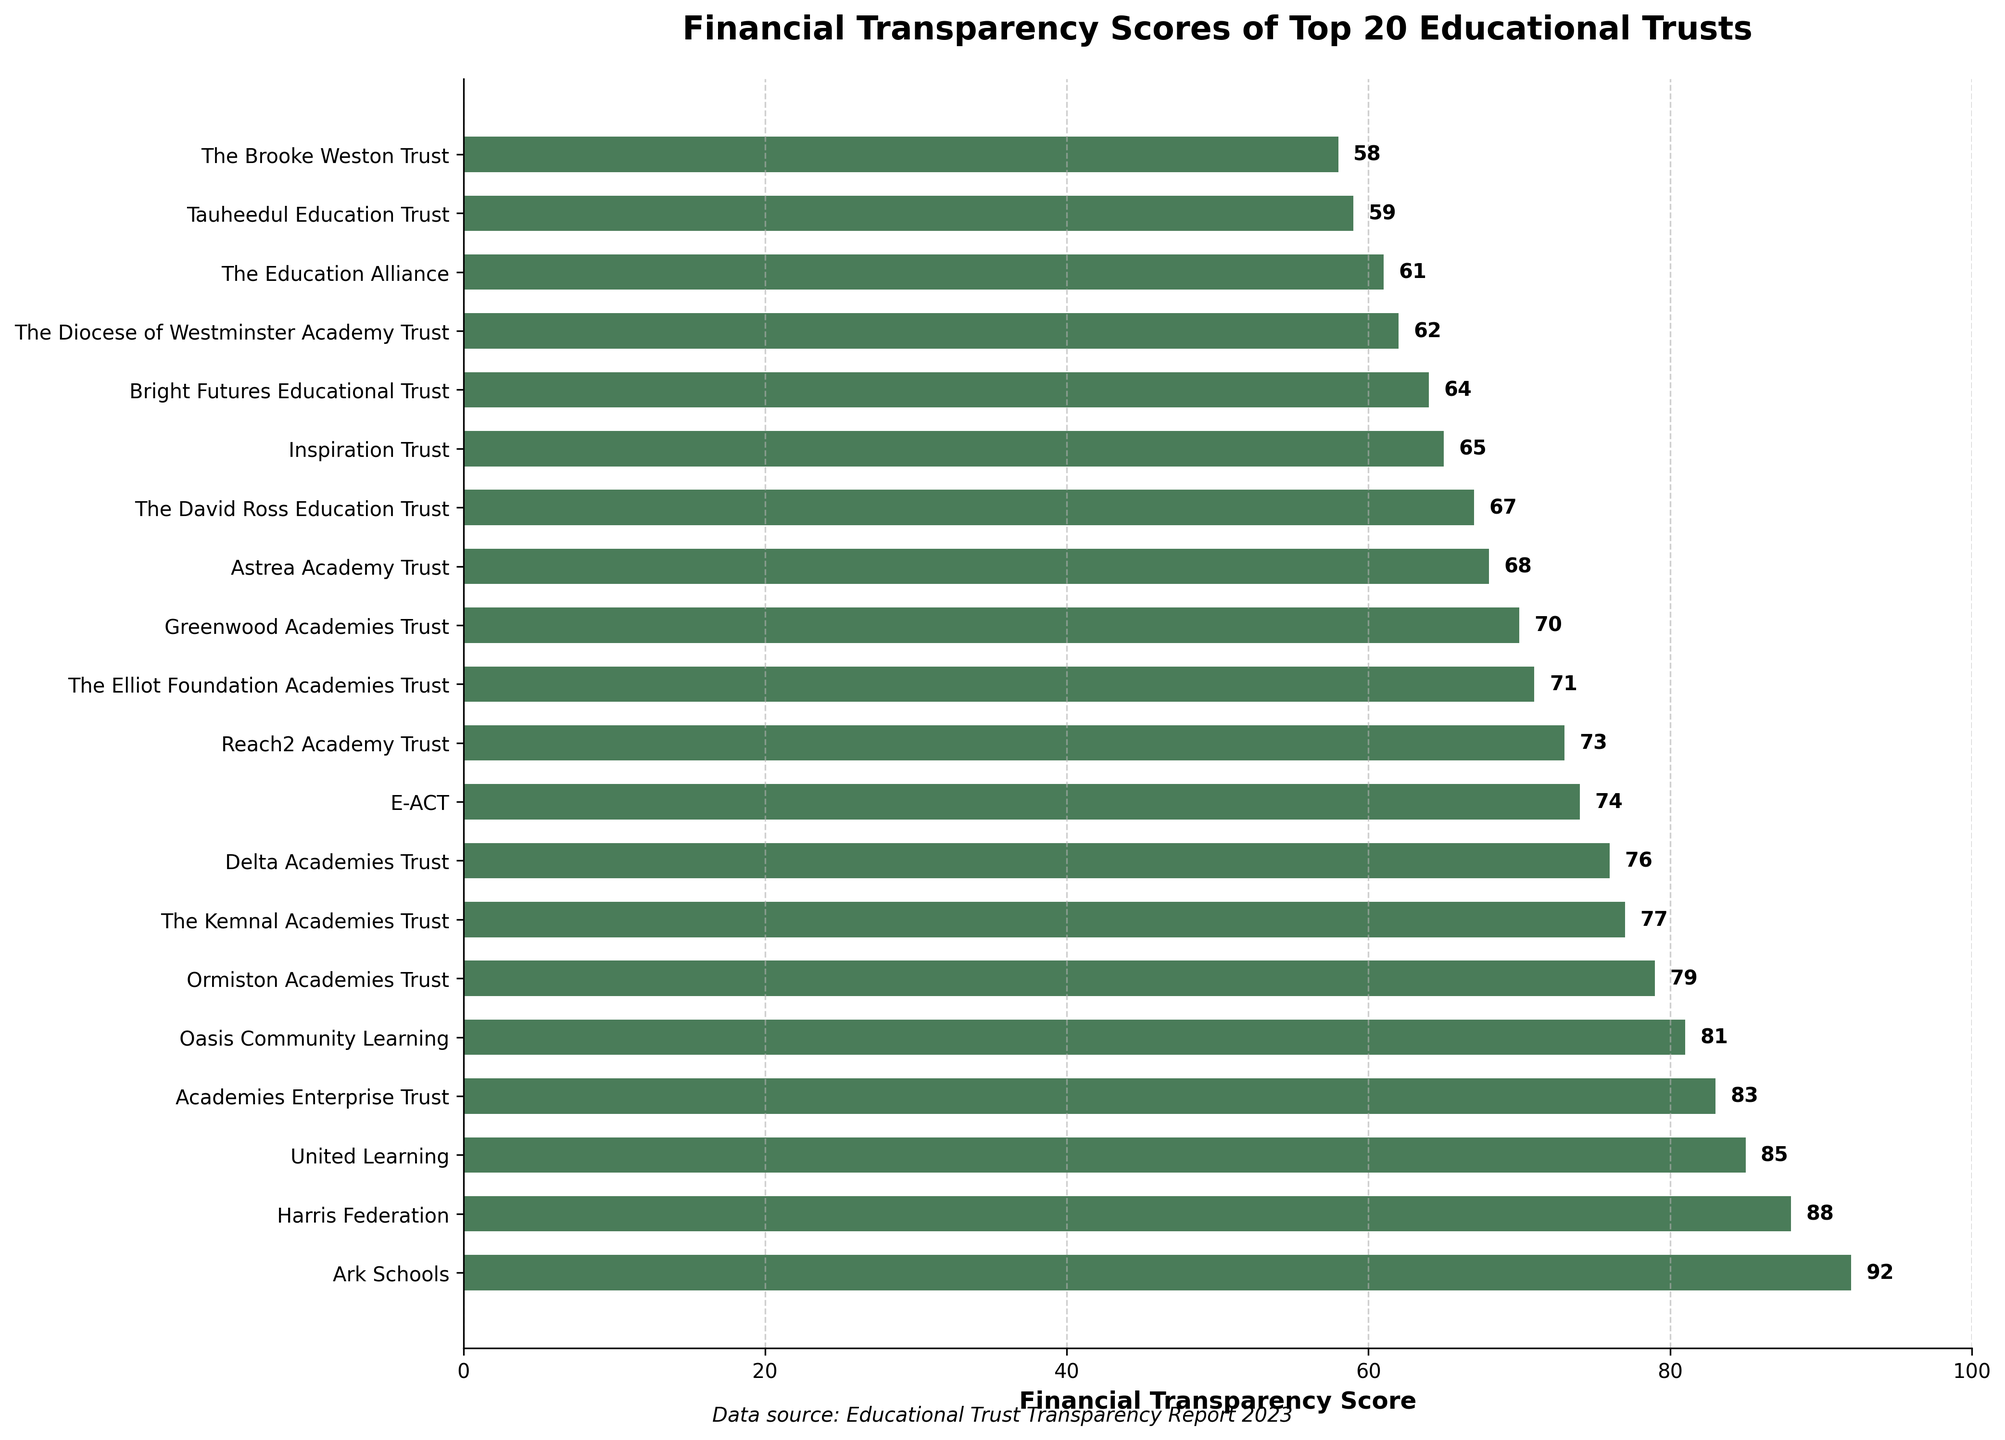Which educational trust has the highest financial transparency score? To find the educational trust with the highest financial transparency score, look for the bar that extends the farthest to the right on the horizontal bar chart. In this case, it is Ark Schools.
Answer: Ark Schools What is the financial transparency score of The Brooke Weston Trust? Scan the y-axis labels to locate The Brooke Weston Trust. The corresponding bar length indicates its financial transparency score, which is 58.
Answer: 58 What is the difference in financial transparency score between Ark Schools and The Brooke Weston Trust? Locate Ark Schools' score (92) and The Brooke Weston Trust's score (58). Subtract the smaller score from the larger one: 92 - 58 = 34.
Answer: 34 Which trust has a financial transparency score closest to 70? Look for the bar whose tip is closest to the 70 mark on the x-axis. Greenwood Academies Trust has a score of 70.
Answer: Greenwood Academies Trust How many trusts have a financial transparency score above 80? Count the number of bars that extend beyond the 80 mark on the x-axis. There are five trusts: Ark Schools, Harris Federation, United Learning, Academies Enterprise Trust, and Oasis Community Learning.
Answer: 5 Which trusts have financial transparency scores that are lower than 65 but higher than 60? Identify bars with scores higher than 60 but lower than 65. The bars corresponding to Bright Futures Educational Trust (64), The Diocese of Westminster Academy Trust (62), and The Education Alliance (61) fall into this range.
Answer: Bright Futures Educational Trust, The Diocese of Westminster Academy Trust, The Education Alliance What is the average financial transparency score of the educational trusts shown in the figure? Sum all the financial transparency scores and then divide by the number of trusts. The total is 1434, and there are 20 trusts. The average score is 1434 / 20 = 71.7.
Answer: 71.7 Compare the financial transparency scores of E-ACT and Reach2 Academy Trust. Which one has a higher score and by how much? Locate E-ACT's score (74) and Reach2 Academy Trust's score (73). Subtract Reach2 Academy Trust's score from E-ACT's score: 74 - 73 = 1. E-ACT has a higher score by 1 point.
Answer: E-ACT, by 1 point What is the total financial transparency score of trusts whose names contain the word "Academy"? Identify the trusts containing "Academy" and sum their scores: Delta Academies Trust (76), Reach2 Academy Trust (73), The Elliot Foundation Academies Trust (71), Greenwood Academies Trust (70), Astrea Academy Trust (68), and Inspiration Trust (65). Total is 76 + 73 + 71 + 70 + 68 + 65 = 423.
Answer: 423 